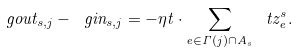Convert formula to latex. <formula><loc_0><loc_0><loc_500><loc_500>\ g o u t _ { s , j } - \ g i n _ { s , j } = - \eta t \cdot \sum _ { e \in \Gamma ( j ) \cap A _ { s } } \ t z ^ { s } _ { e } .</formula> 